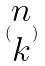Convert formula to latex. <formula><loc_0><loc_0><loc_500><loc_500>( \begin{matrix} n \\ k \end{matrix} )</formula> 